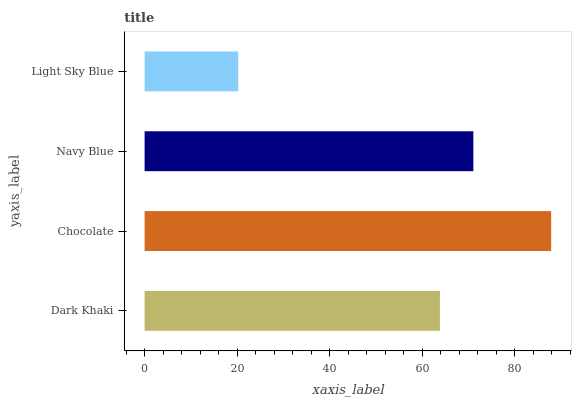Is Light Sky Blue the minimum?
Answer yes or no. Yes. Is Chocolate the maximum?
Answer yes or no. Yes. Is Navy Blue the minimum?
Answer yes or no. No. Is Navy Blue the maximum?
Answer yes or no. No. Is Chocolate greater than Navy Blue?
Answer yes or no. Yes. Is Navy Blue less than Chocolate?
Answer yes or no. Yes. Is Navy Blue greater than Chocolate?
Answer yes or no. No. Is Chocolate less than Navy Blue?
Answer yes or no. No. Is Navy Blue the high median?
Answer yes or no. Yes. Is Dark Khaki the low median?
Answer yes or no. Yes. Is Light Sky Blue the high median?
Answer yes or no. No. Is Navy Blue the low median?
Answer yes or no. No. 